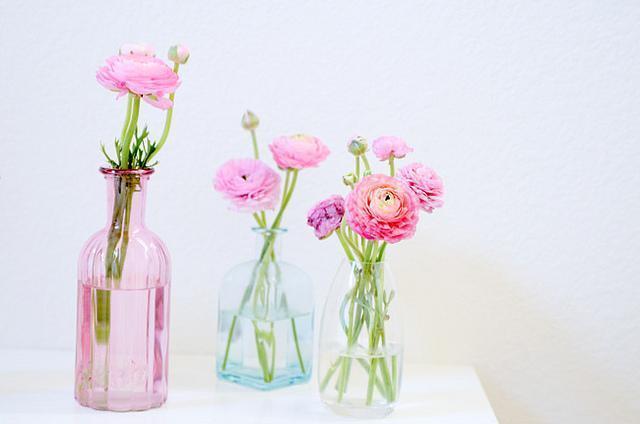How many of the roses are red?
Give a very brief answer. 0. How many different vase designs are there?
Give a very brief answer. 3. How many flowers are orange?
Give a very brief answer. 0. How many different items are visible?
Give a very brief answer. 3. How many vases are there?
Give a very brief answer. 3. 